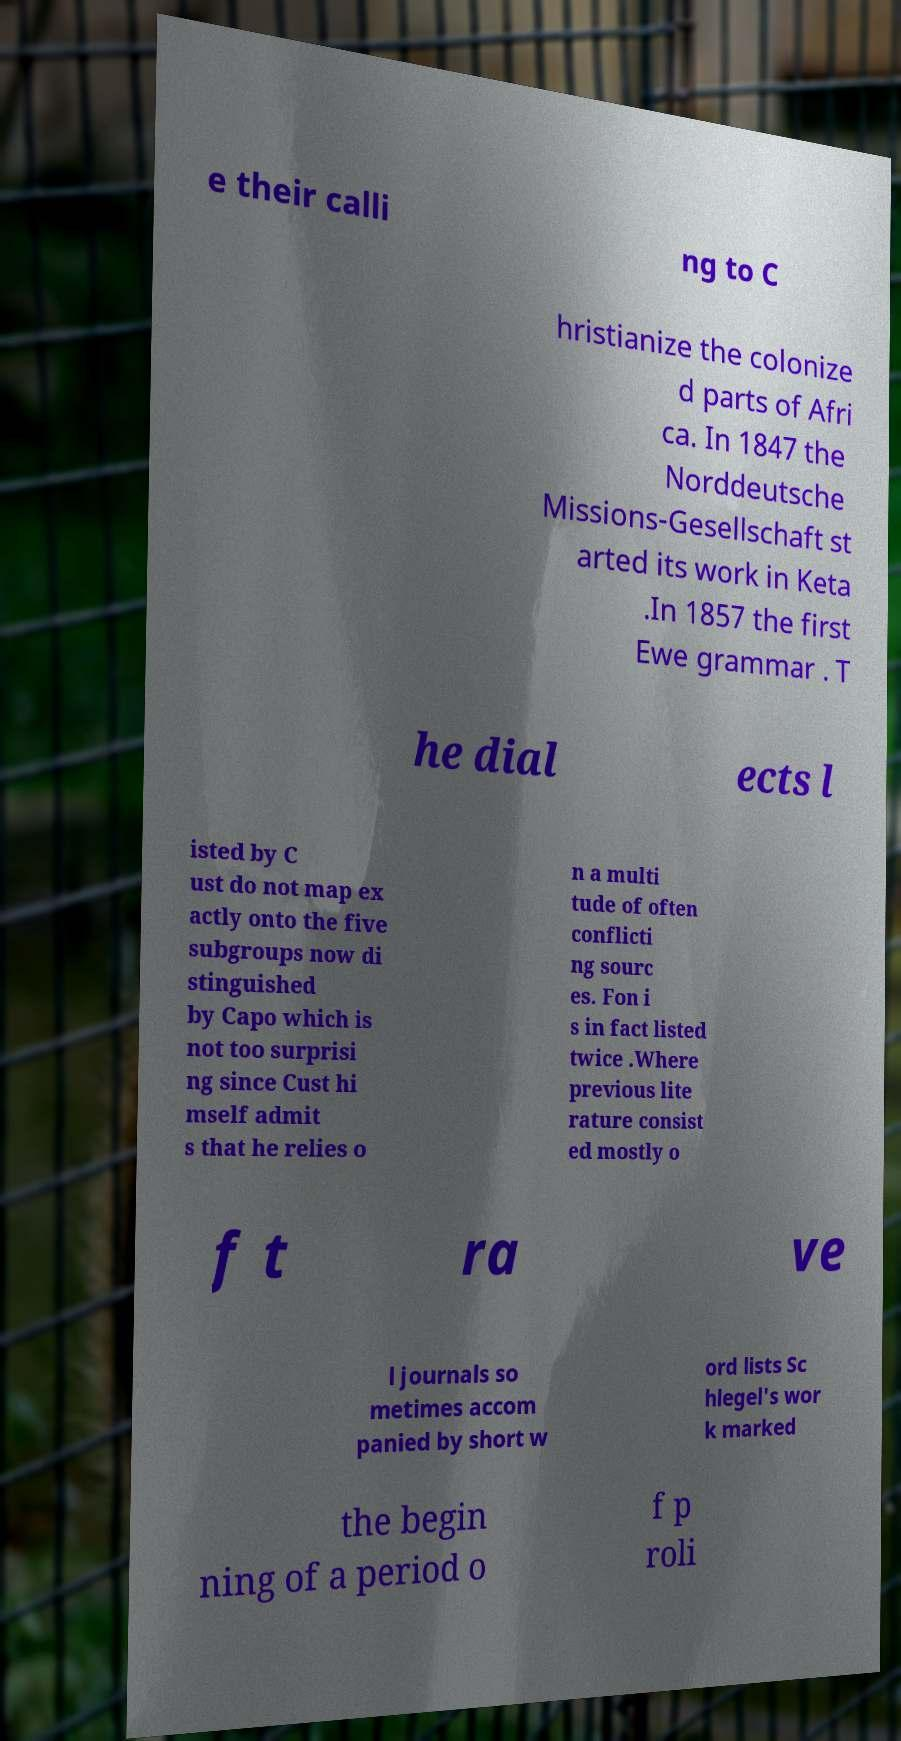Can you accurately transcribe the text from the provided image for me? e their calli ng to C hristianize the colonize d parts of Afri ca. In 1847 the Norddeutsche Missions-Gesellschaft st arted its work in Keta .In 1857 the first Ewe grammar . T he dial ects l isted by C ust do not map ex actly onto the five subgroups now di stinguished by Capo which is not too surprisi ng since Cust hi mself admit s that he relies o n a multi tude of often conflicti ng sourc es. Fon i s in fact listed twice .Where previous lite rature consist ed mostly o f t ra ve l journals so metimes accom panied by short w ord lists Sc hlegel's wor k marked the begin ning of a period o f p roli 